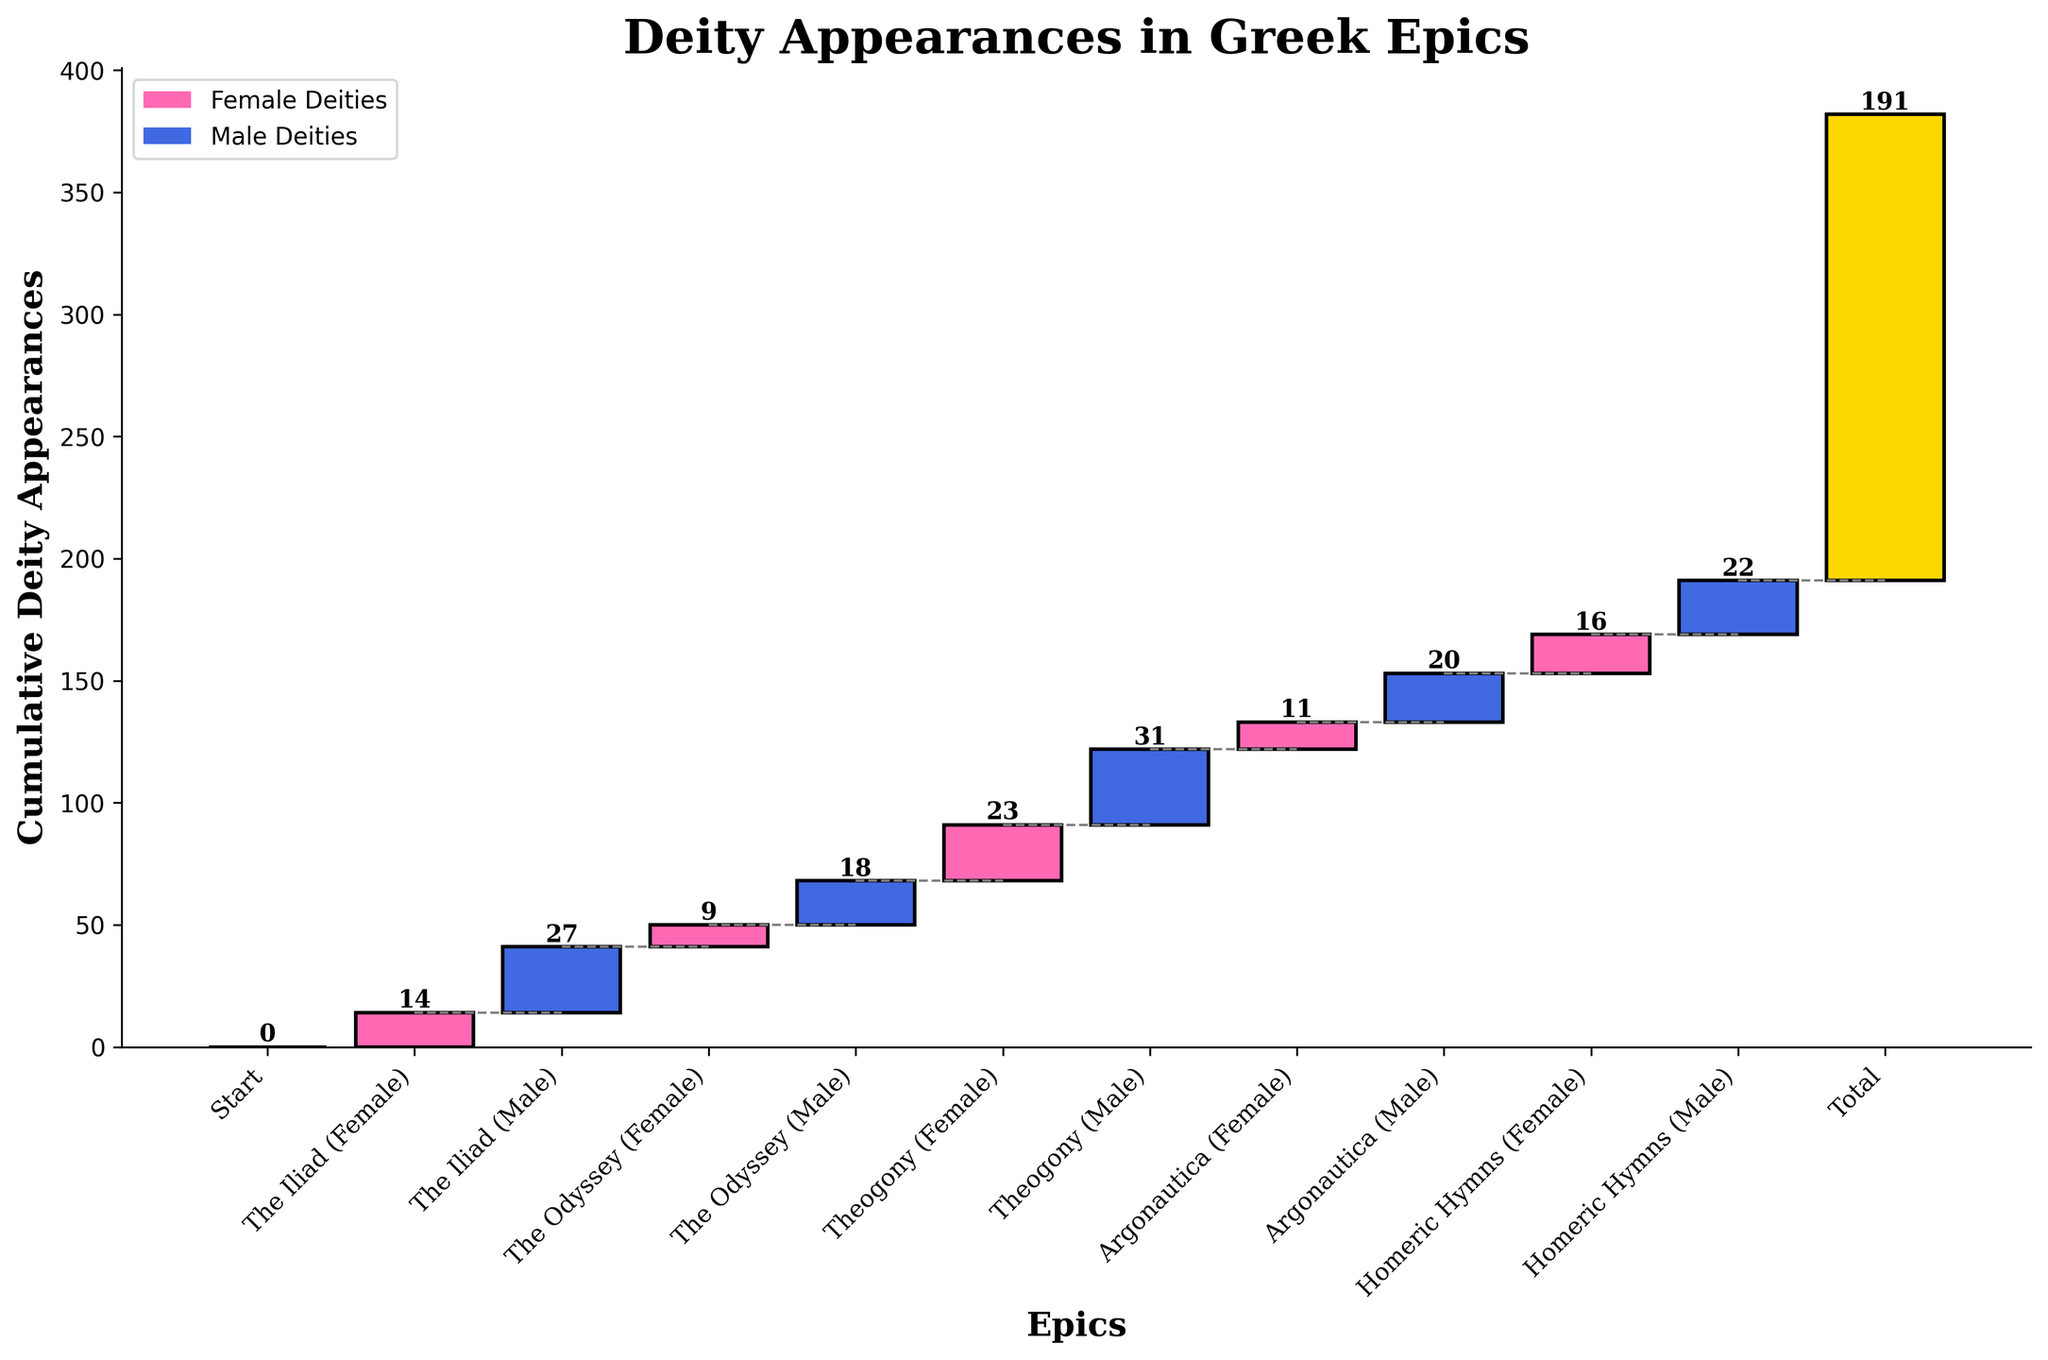What is the title of the figure? The title is usually located at the top of the figure. In this case, it reads "Deity Appearances in Greek Epics".
Answer: Deity Appearances in Greek Epics Which epic has the highest number of female deity appearances? Looking at the bars, the Theogony (Female) category has the highest bar among female deities.
Answer: Theogony How many female deities appear in the Homeric Hymns? The bar labeled Homeric Hymns (Female) has a label indicating the number of female deity appearances. This label reads 16.
Answer: 16 What is the cumulative total of appearances just before the Argonautica epic (Male and Female) is added? To find this, we must look at the cumulative total after the Theogony (Male) bar. Using the waterfall chart, add the values from previous categories up to and including Theogony (Male): 14 + 27 + 9 + 18 + 23 + 31. Sum these and we get 122.
Answer: 122 Which gender has more deity appearances in The Iliad? By comparing the heights of the bars labeled The Iliad (Female) and The Iliad (Male), the male category has a higher bar.
Answer: Male How much larger is the total number of male deity appearances compared to female deity appearances across all epics? Sum all male appearances: 27 + 18 + 31 + 20 + 22 = 118. Sum all female appearances: 14 + 9 + 23 + 11 + 16 = 73. Subtract the totals: 118 - 73 to get the difference.
Answer: 45 What proportion of total deity appearances does the Odyssey (Female) represent? The total number of deity appearances is 191. The Odyssey (Female) value is 9. So, the proportion is 9/191.
Answer: 9/191 By how much does the total deity appearance increase from The Iliad (Male) to The Odyssey (Male)? To find this increase, compute the difference between the cumulative totals at these points. Cumulative total at The Iliad (Male) is 41 (14 + 27) and for The Odyssey (Male) it is 68 (41 + 9 + 18). Subtract the first cumulative total from the second: 68 - 41.
Answer: 27 